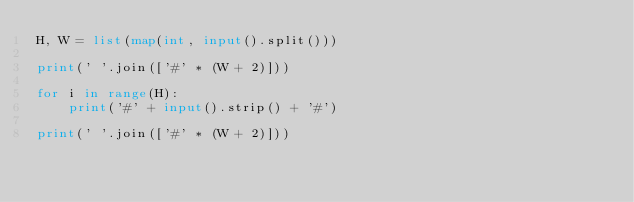<code> <loc_0><loc_0><loc_500><loc_500><_Python_>H, W = list(map(int, input().split()))

print(' '.join(['#' * (W + 2)]))

for i in range(H):
    print('#' + input().strip() + '#')

print(' '.join(['#' * (W + 2)]))


    </code> 